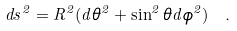Convert formula to latex. <formula><loc_0><loc_0><loc_500><loc_500>d s ^ { 2 } = R ^ { 2 } ( d \theta ^ { 2 } + \sin ^ { 2 } \theta d \phi ^ { 2 } ) \ .</formula> 